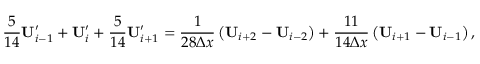<formula> <loc_0><loc_0><loc_500><loc_500>\frac { 5 } { 1 4 } U _ { i - 1 } ^ { \prime } + U _ { i } ^ { \prime } + \frac { 5 } { 1 4 } U _ { i + 1 } ^ { \prime } = \frac { 1 } { 2 8 \Delta x } \left ( U _ { i + 2 } - U _ { i - 2 } \right ) + \frac { 1 1 } { 1 4 \Delta x } \left ( U _ { i + 1 } - U _ { i - 1 } \right ) ,</formula> 